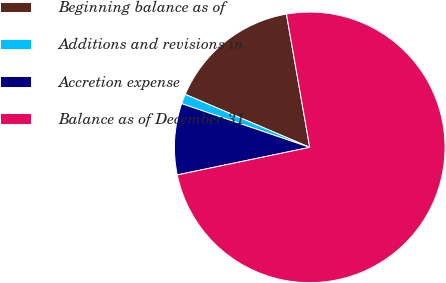<chart> <loc_0><loc_0><loc_500><loc_500><pie_chart><fcel>Beginning balance as of<fcel>Additions and revisions in<fcel>Accretion expense<fcel>Balance as of December 31<nl><fcel>15.84%<fcel>1.17%<fcel>8.5%<fcel>74.49%<nl></chart> 